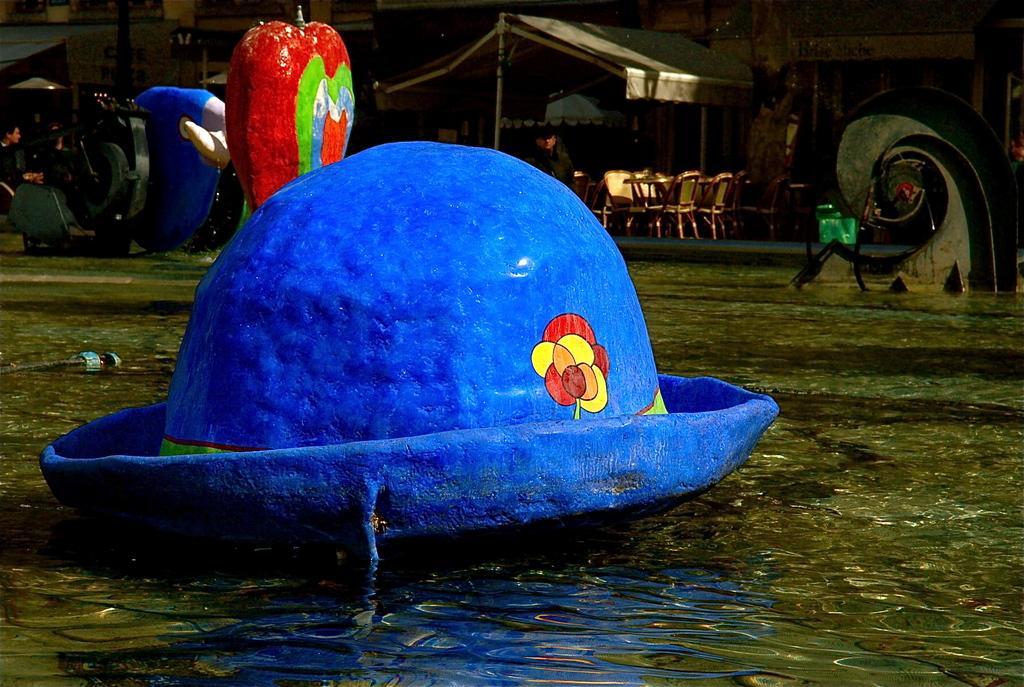Can you describe this image briefly? In this image in the front there is a hat which is blue in colour. In the background there are chairs, there is a tent, there are persons and there are objects which are red and blue in colour and there are buildings. 